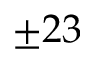Convert formula to latex. <formula><loc_0><loc_0><loc_500><loc_500>\pm 2 3</formula> 